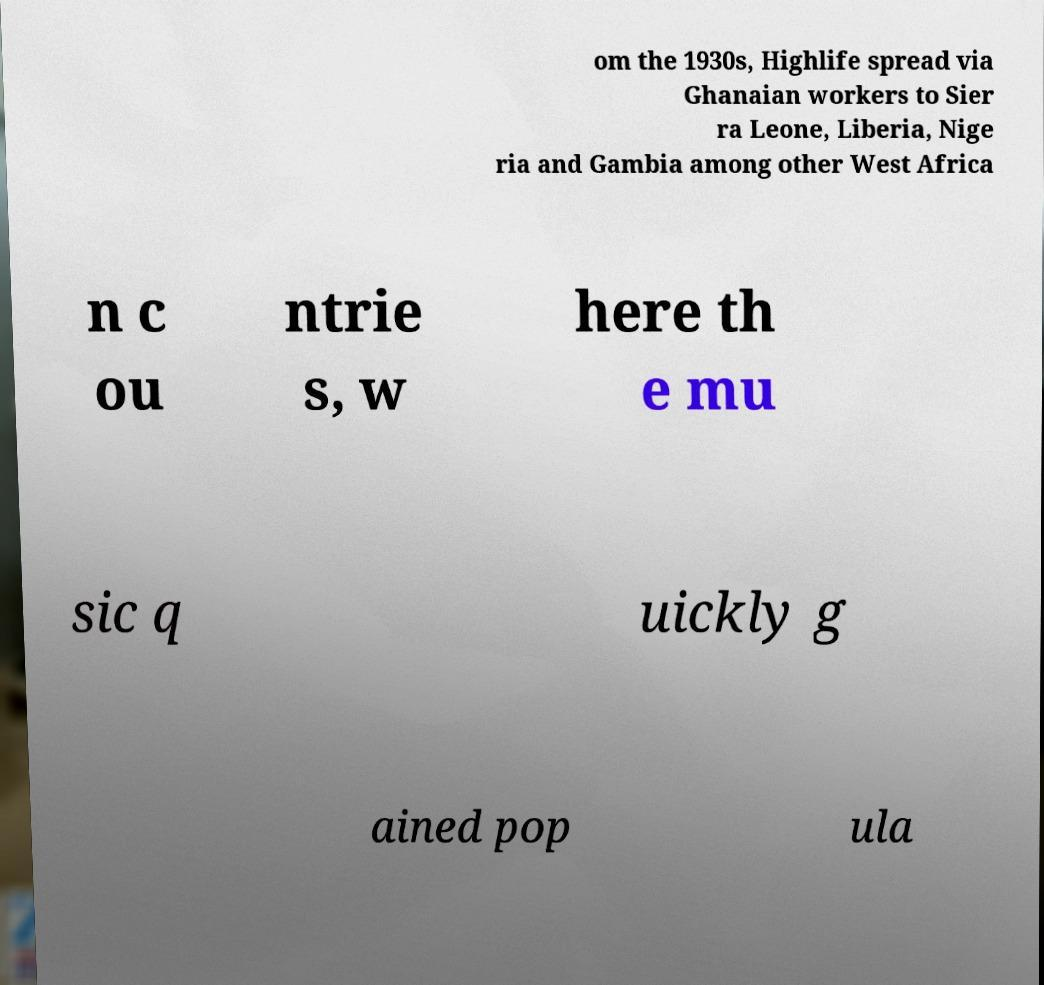Could you assist in decoding the text presented in this image and type it out clearly? om the 1930s, Highlife spread via Ghanaian workers to Sier ra Leone, Liberia, Nige ria and Gambia among other West Africa n c ou ntrie s, w here th e mu sic q uickly g ained pop ula 